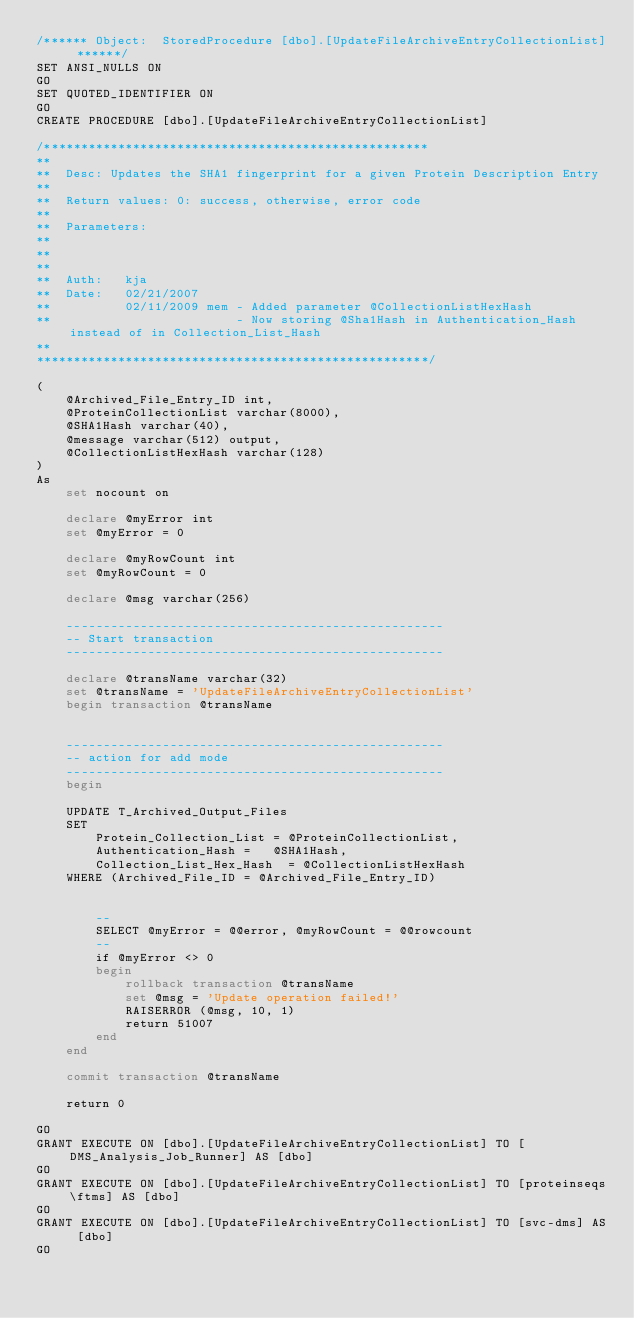Convert code to text. <code><loc_0><loc_0><loc_500><loc_500><_SQL_>/****** Object:  StoredProcedure [dbo].[UpdateFileArchiveEntryCollectionList] ******/
SET ANSI_NULLS ON
GO
SET QUOTED_IDENTIFIER ON
GO
CREATE PROCEDURE [dbo].[UpdateFileArchiveEntryCollectionList]

/****************************************************
**
**	Desc: Updates the SHA1 fingerprint for a given Protein Description Entry
**
**	Return values: 0: success, otherwise, error code
**
**	Parameters: 
**
**	
**
**	Auth:	kja
**	Date:	02/21/2007
**			02/11/2009 mem - Added parameter @CollectionListHexHash
**						   - Now storing @Sha1Hash in Authentication_Hash instead of in Collection_List_Hash
**    
*****************************************************/

(
	@Archived_File_Entry_ID int,
	@ProteinCollectionList varchar(8000),
	@SHA1Hash varchar(40),
	@message varchar(512) output,
	@CollectionListHexHash varchar(128)
)
As
	set nocount on

	declare @myError int
	set @myError = 0

	declare @myRowCount int
	set @myRowCount = 0
	
	declare @msg varchar(256)

	---------------------------------------------------
	-- Start transaction
	---------------------------------------------------

	declare @transName varchar(32)
	set @transName = 'UpdateFileArchiveEntryCollectionList'
	begin transaction @transName


	---------------------------------------------------
	-- action for add mode
	---------------------------------------------------
	begin

	UPDATE T_Archived_Output_Files
	SET 
		Protein_Collection_List = @ProteinCollectionList,
		Authentication_Hash = 	@SHA1Hash,
		Collection_List_Hex_Hash  = @CollectionListHexHash
	WHERE (Archived_File_ID = @Archived_File_Entry_ID)	
		
				
		--
		SELECT @myError = @@error, @myRowCount = @@rowcount
		--
		if @myError <> 0
		begin
			rollback transaction @transName
			set @msg = 'Update operation failed!'
			RAISERROR (@msg, 10, 1)
			return 51007
		end
	end
		
	commit transaction @transName
	
	return 0

GO
GRANT EXECUTE ON [dbo].[UpdateFileArchiveEntryCollectionList] TO [DMS_Analysis_Job_Runner] AS [dbo]
GO
GRANT EXECUTE ON [dbo].[UpdateFileArchiveEntryCollectionList] TO [proteinseqs\ftms] AS [dbo]
GO
GRANT EXECUTE ON [dbo].[UpdateFileArchiveEntryCollectionList] TO [svc-dms] AS [dbo]
GO
</code> 